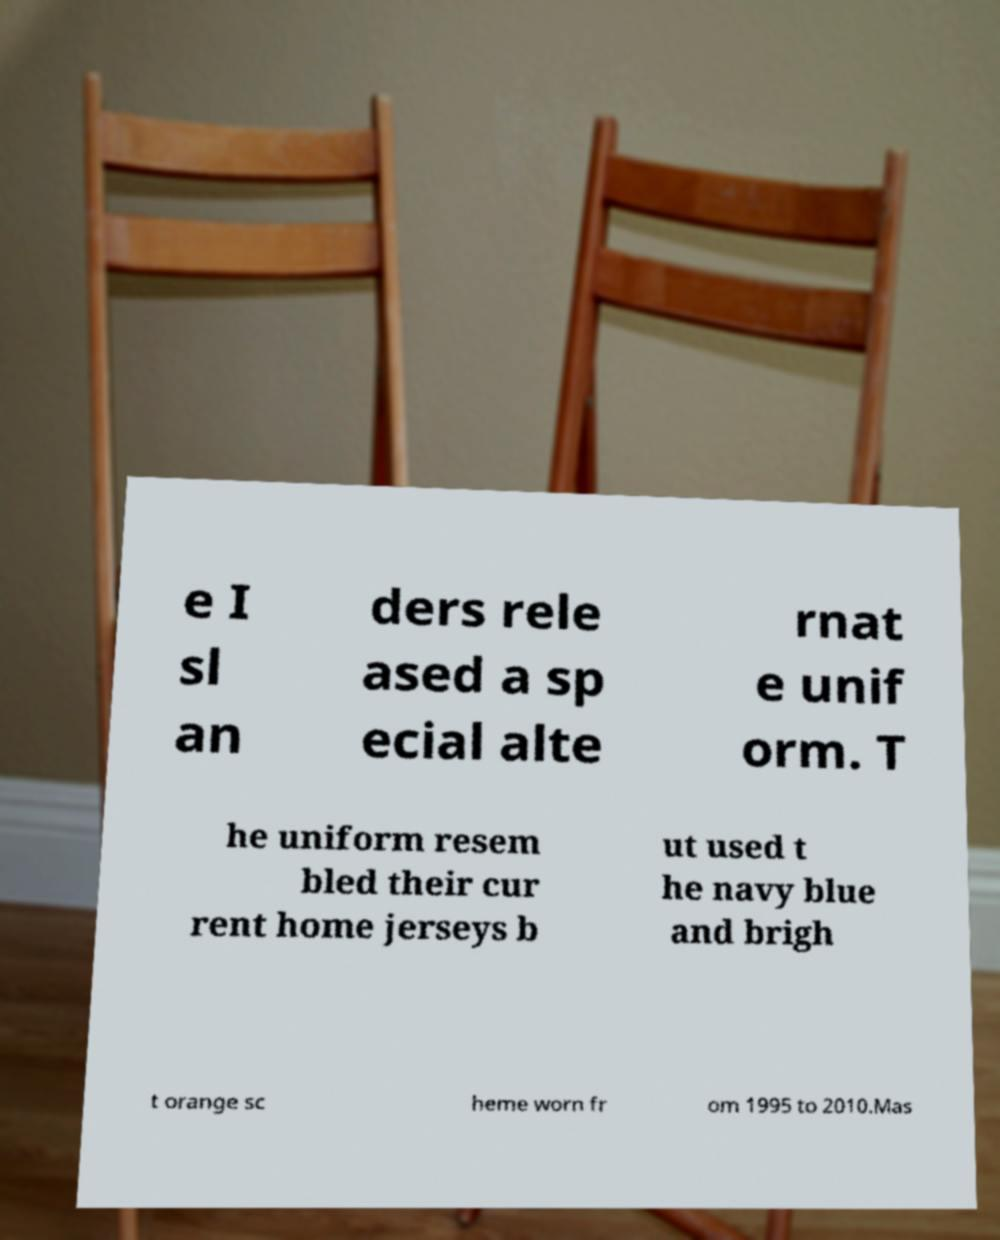There's text embedded in this image that I need extracted. Can you transcribe it verbatim? e I sl an ders rele ased a sp ecial alte rnat e unif orm. T he uniform resem bled their cur rent home jerseys b ut used t he navy blue and brigh t orange sc heme worn fr om 1995 to 2010.Mas 